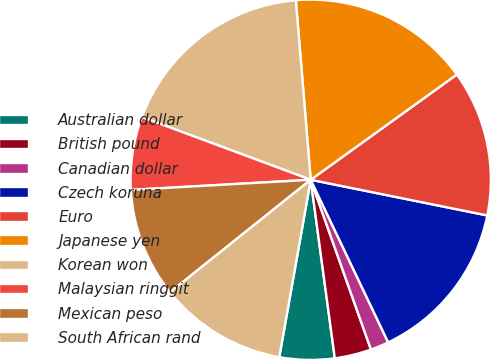Convert chart to OTSL. <chart><loc_0><loc_0><loc_500><loc_500><pie_chart><fcel>Australian dollar<fcel>British pound<fcel>Canadian dollar<fcel>Czech koruna<fcel>Euro<fcel>Japanese yen<fcel>Korean won<fcel>Malaysian ringgit<fcel>Mexican peso<fcel>South African rand<nl><fcel>4.93%<fcel>3.29%<fcel>1.65%<fcel>14.75%<fcel>13.11%<fcel>16.38%<fcel>18.02%<fcel>6.56%<fcel>9.84%<fcel>11.47%<nl></chart> 